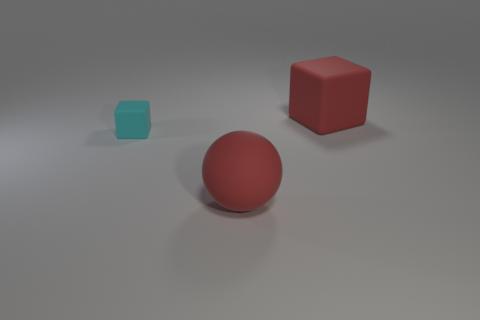There is a rubber object to the left of the big thing left of the red rubber thing behind the tiny cyan object; what shape is it?
Your answer should be very brief. Cube. There is a red rubber object behind the red matte ball; how big is it?
Offer a terse response. Large. There is a red object that is the same size as the ball; what shape is it?
Your answer should be very brief. Cube. What number of objects are small yellow metallic spheres or large red matte blocks on the right side of the cyan object?
Provide a short and direct response. 1. There is a big rubber object in front of the rubber cube on the left side of the red block; what number of matte cubes are to the right of it?
Ensure brevity in your answer.  1. There is a cube that is made of the same material as the tiny object; what color is it?
Your answer should be very brief. Red. There is a block that is to the right of the red rubber ball; is its size the same as the tiny cyan matte object?
Provide a succinct answer. No. What number of things are small cyan cubes or big rubber spheres?
Keep it short and to the point. 2. What material is the thing to the left of the large red object left of the large red object to the right of the red ball made of?
Provide a succinct answer. Rubber. What material is the large object in front of the big red block?
Provide a short and direct response. Rubber. 